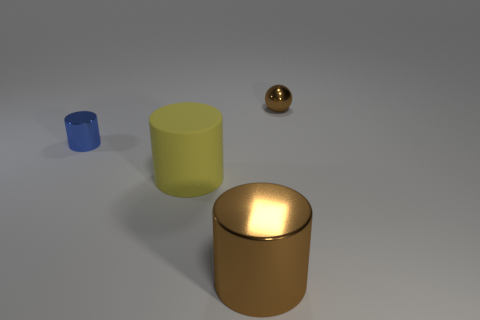Do the small metallic sphere and the big metal thing have the same color?
Give a very brief answer. Yes. Is there any other thing that has the same shape as the small brown object?
Give a very brief answer. No. The yellow matte thing has what shape?
Ensure brevity in your answer.  Cylinder. How many large objects are yellow rubber cylinders or brown spheres?
Ensure brevity in your answer.  1. The brown shiny object that is the same shape as the large yellow rubber thing is what size?
Your answer should be very brief. Large. What number of tiny things are both behind the blue object and in front of the tiny brown metallic object?
Offer a very short reply. 0. Does the blue metallic object have the same shape as the small metallic object to the right of the yellow matte object?
Offer a very short reply. No. Are there more big rubber objects to the right of the small ball than tiny cyan matte cylinders?
Make the answer very short. No. Is the number of yellow matte objects behind the small brown shiny ball less than the number of objects?
Make the answer very short. Yes. What number of big things are the same color as the sphere?
Keep it short and to the point. 1. 